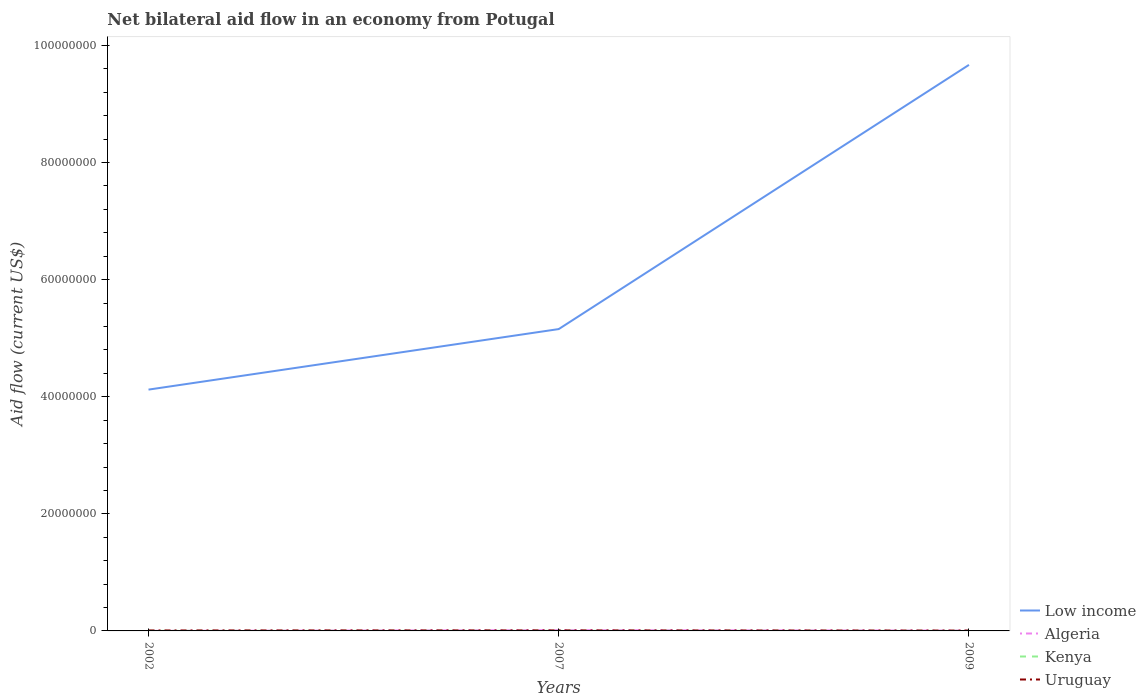How many different coloured lines are there?
Offer a terse response. 4. Across all years, what is the maximum net bilateral aid flow in Low income?
Your response must be concise. 4.12e+07. In which year was the net bilateral aid flow in Low income maximum?
Your answer should be compact. 2002. What is the total net bilateral aid flow in Kenya in the graph?
Ensure brevity in your answer.  -10000. What is the difference between the highest and the second highest net bilateral aid flow in Low income?
Keep it short and to the point. 5.55e+07. What is the difference between the highest and the lowest net bilateral aid flow in Uruguay?
Give a very brief answer. 2. How many lines are there?
Keep it short and to the point. 4. How many years are there in the graph?
Provide a short and direct response. 3. Does the graph contain any zero values?
Give a very brief answer. No. How are the legend labels stacked?
Keep it short and to the point. Vertical. What is the title of the graph?
Ensure brevity in your answer.  Net bilateral aid flow in an economy from Potugal. What is the label or title of the Y-axis?
Provide a succinct answer. Aid flow (current US$). What is the Aid flow (current US$) of Low income in 2002?
Offer a terse response. 4.12e+07. What is the Aid flow (current US$) in Kenya in 2002?
Make the answer very short. 10000. What is the Aid flow (current US$) of Uruguay in 2002?
Offer a terse response. 8.00e+04. What is the Aid flow (current US$) of Low income in 2007?
Make the answer very short. 5.16e+07. What is the Aid flow (current US$) of Low income in 2009?
Provide a short and direct response. 9.67e+07. What is the Aid flow (current US$) of Algeria in 2009?
Your response must be concise. 6.00e+04. Across all years, what is the maximum Aid flow (current US$) of Low income?
Keep it short and to the point. 9.67e+07. Across all years, what is the maximum Aid flow (current US$) in Algeria?
Provide a short and direct response. 1.30e+05. Across all years, what is the maximum Aid flow (current US$) in Kenya?
Offer a very short reply. 2.00e+04. Across all years, what is the minimum Aid flow (current US$) of Low income?
Your response must be concise. 4.12e+07. Across all years, what is the minimum Aid flow (current US$) of Uruguay?
Give a very brief answer. 6.00e+04. What is the total Aid flow (current US$) of Low income in the graph?
Provide a succinct answer. 1.89e+08. What is the total Aid flow (current US$) of Kenya in the graph?
Your answer should be very brief. 4.00e+04. What is the difference between the Aid flow (current US$) in Low income in 2002 and that in 2007?
Provide a short and direct response. -1.03e+07. What is the difference between the Aid flow (current US$) in Algeria in 2002 and that in 2007?
Offer a terse response. -1.20e+05. What is the difference between the Aid flow (current US$) of Uruguay in 2002 and that in 2007?
Keep it short and to the point. -10000. What is the difference between the Aid flow (current US$) of Low income in 2002 and that in 2009?
Ensure brevity in your answer.  -5.55e+07. What is the difference between the Aid flow (current US$) of Kenya in 2002 and that in 2009?
Your answer should be compact. 0. What is the difference between the Aid flow (current US$) in Low income in 2007 and that in 2009?
Make the answer very short. -4.51e+07. What is the difference between the Aid flow (current US$) of Algeria in 2007 and that in 2009?
Provide a succinct answer. 7.00e+04. What is the difference between the Aid flow (current US$) of Kenya in 2007 and that in 2009?
Give a very brief answer. 10000. What is the difference between the Aid flow (current US$) of Uruguay in 2007 and that in 2009?
Offer a terse response. 3.00e+04. What is the difference between the Aid flow (current US$) in Low income in 2002 and the Aid flow (current US$) in Algeria in 2007?
Offer a terse response. 4.11e+07. What is the difference between the Aid flow (current US$) in Low income in 2002 and the Aid flow (current US$) in Kenya in 2007?
Provide a succinct answer. 4.12e+07. What is the difference between the Aid flow (current US$) of Low income in 2002 and the Aid flow (current US$) of Uruguay in 2007?
Offer a terse response. 4.11e+07. What is the difference between the Aid flow (current US$) in Kenya in 2002 and the Aid flow (current US$) in Uruguay in 2007?
Keep it short and to the point. -8.00e+04. What is the difference between the Aid flow (current US$) in Low income in 2002 and the Aid flow (current US$) in Algeria in 2009?
Offer a very short reply. 4.12e+07. What is the difference between the Aid flow (current US$) of Low income in 2002 and the Aid flow (current US$) of Kenya in 2009?
Give a very brief answer. 4.12e+07. What is the difference between the Aid flow (current US$) of Low income in 2002 and the Aid flow (current US$) of Uruguay in 2009?
Give a very brief answer. 4.12e+07. What is the difference between the Aid flow (current US$) of Algeria in 2002 and the Aid flow (current US$) of Uruguay in 2009?
Provide a short and direct response. -5.00e+04. What is the difference between the Aid flow (current US$) in Low income in 2007 and the Aid flow (current US$) in Algeria in 2009?
Provide a succinct answer. 5.15e+07. What is the difference between the Aid flow (current US$) of Low income in 2007 and the Aid flow (current US$) of Kenya in 2009?
Keep it short and to the point. 5.16e+07. What is the difference between the Aid flow (current US$) in Low income in 2007 and the Aid flow (current US$) in Uruguay in 2009?
Provide a succinct answer. 5.15e+07. What is the difference between the Aid flow (current US$) of Algeria in 2007 and the Aid flow (current US$) of Kenya in 2009?
Your response must be concise. 1.20e+05. What is the difference between the Aid flow (current US$) in Algeria in 2007 and the Aid flow (current US$) in Uruguay in 2009?
Make the answer very short. 7.00e+04. What is the difference between the Aid flow (current US$) of Kenya in 2007 and the Aid flow (current US$) of Uruguay in 2009?
Make the answer very short. -4.00e+04. What is the average Aid flow (current US$) in Low income per year?
Offer a very short reply. 6.32e+07. What is the average Aid flow (current US$) of Algeria per year?
Offer a terse response. 6.67e+04. What is the average Aid flow (current US$) of Kenya per year?
Keep it short and to the point. 1.33e+04. What is the average Aid flow (current US$) in Uruguay per year?
Your answer should be very brief. 7.67e+04. In the year 2002, what is the difference between the Aid flow (current US$) of Low income and Aid flow (current US$) of Algeria?
Keep it short and to the point. 4.12e+07. In the year 2002, what is the difference between the Aid flow (current US$) in Low income and Aid flow (current US$) in Kenya?
Give a very brief answer. 4.12e+07. In the year 2002, what is the difference between the Aid flow (current US$) in Low income and Aid flow (current US$) in Uruguay?
Provide a succinct answer. 4.11e+07. In the year 2002, what is the difference between the Aid flow (current US$) of Algeria and Aid flow (current US$) of Kenya?
Provide a succinct answer. 0. In the year 2002, what is the difference between the Aid flow (current US$) of Kenya and Aid flow (current US$) of Uruguay?
Keep it short and to the point. -7.00e+04. In the year 2007, what is the difference between the Aid flow (current US$) of Low income and Aid flow (current US$) of Algeria?
Make the answer very short. 5.14e+07. In the year 2007, what is the difference between the Aid flow (current US$) in Low income and Aid flow (current US$) in Kenya?
Provide a succinct answer. 5.15e+07. In the year 2007, what is the difference between the Aid flow (current US$) in Low income and Aid flow (current US$) in Uruguay?
Offer a terse response. 5.15e+07. In the year 2007, what is the difference between the Aid flow (current US$) in Algeria and Aid flow (current US$) in Kenya?
Ensure brevity in your answer.  1.10e+05. In the year 2009, what is the difference between the Aid flow (current US$) in Low income and Aid flow (current US$) in Algeria?
Your answer should be compact. 9.66e+07. In the year 2009, what is the difference between the Aid flow (current US$) of Low income and Aid flow (current US$) of Kenya?
Ensure brevity in your answer.  9.67e+07. In the year 2009, what is the difference between the Aid flow (current US$) in Low income and Aid flow (current US$) in Uruguay?
Provide a short and direct response. 9.66e+07. In the year 2009, what is the difference between the Aid flow (current US$) of Algeria and Aid flow (current US$) of Kenya?
Make the answer very short. 5.00e+04. What is the ratio of the Aid flow (current US$) in Low income in 2002 to that in 2007?
Your response must be concise. 0.8. What is the ratio of the Aid flow (current US$) in Algeria in 2002 to that in 2007?
Make the answer very short. 0.08. What is the ratio of the Aid flow (current US$) in Kenya in 2002 to that in 2007?
Keep it short and to the point. 0.5. What is the ratio of the Aid flow (current US$) in Uruguay in 2002 to that in 2007?
Provide a succinct answer. 0.89. What is the ratio of the Aid flow (current US$) of Low income in 2002 to that in 2009?
Provide a short and direct response. 0.43. What is the ratio of the Aid flow (current US$) in Algeria in 2002 to that in 2009?
Keep it short and to the point. 0.17. What is the ratio of the Aid flow (current US$) of Low income in 2007 to that in 2009?
Ensure brevity in your answer.  0.53. What is the ratio of the Aid flow (current US$) in Algeria in 2007 to that in 2009?
Keep it short and to the point. 2.17. What is the difference between the highest and the second highest Aid flow (current US$) in Low income?
Provide a short and direct response. 4.51e+07. What is the difference between the highest and the second highest Aid flow (current US$) of Kenya?
Your answer should be very brief. 10000. What is the difference between the highest and the lowest Aid flow (current US$) of Low income?
Your answer should be very brief. 5.55e+07. What is the difference between the highest and the lowest Aid flow (current US$) in Kenya?
Keep it short and to the point. 10000. What is the difference between the highest and the lowest Aid flow (current US$) of Uruguay?
Your answer should be very brief. 3.00e+04. 